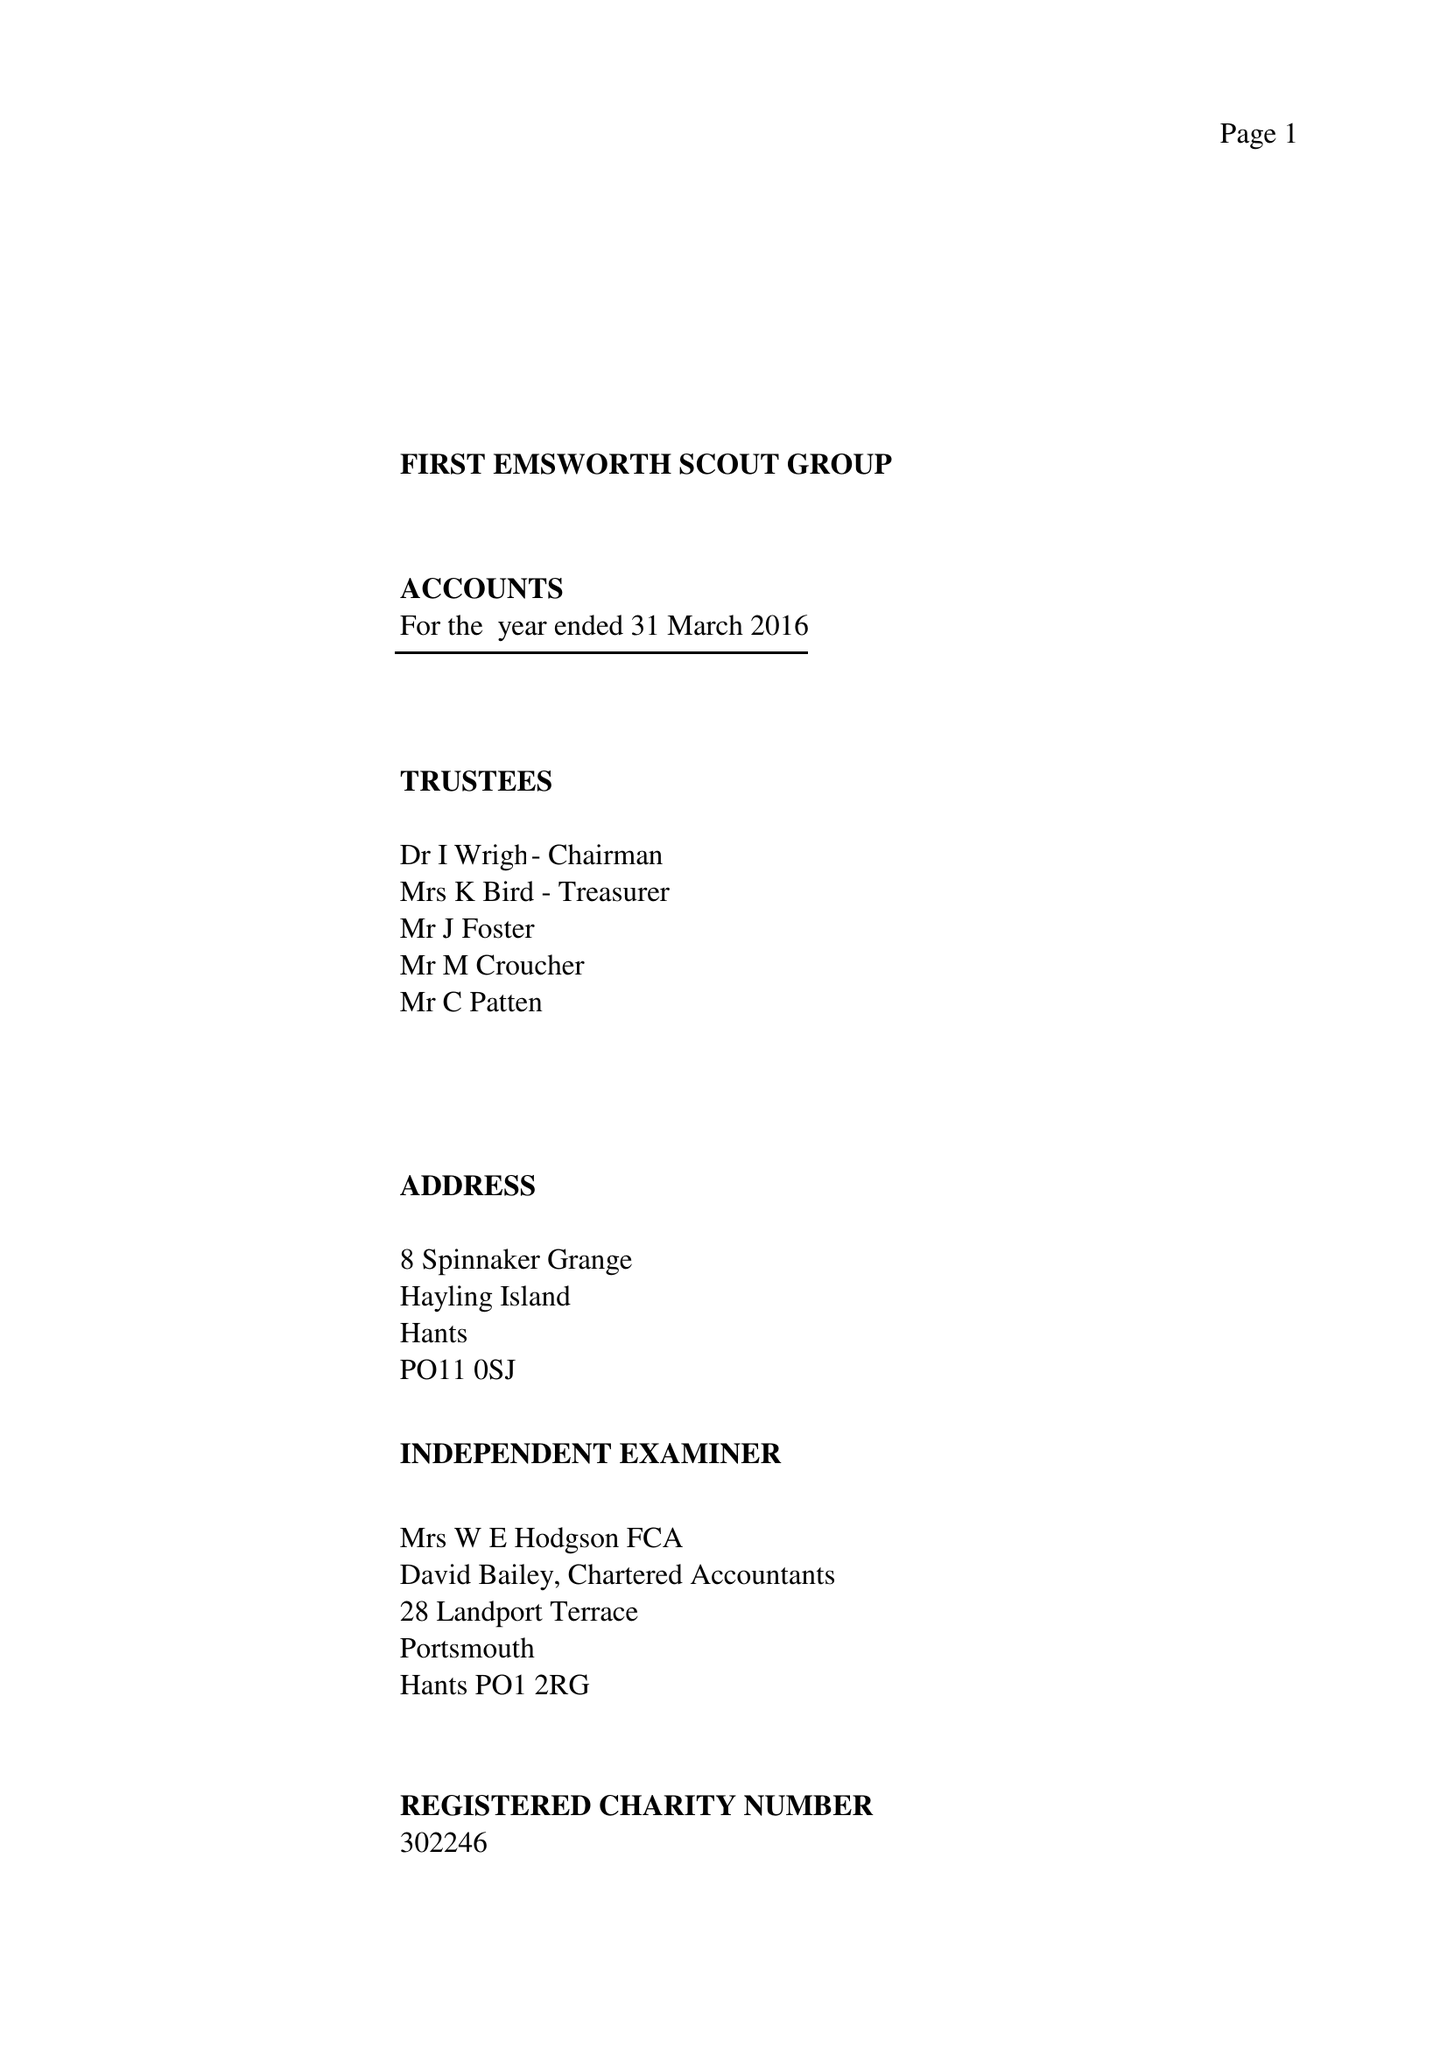What is the value for the address__post_town?
Answer the question using a single word or phrase. HAYLING ISLAND 